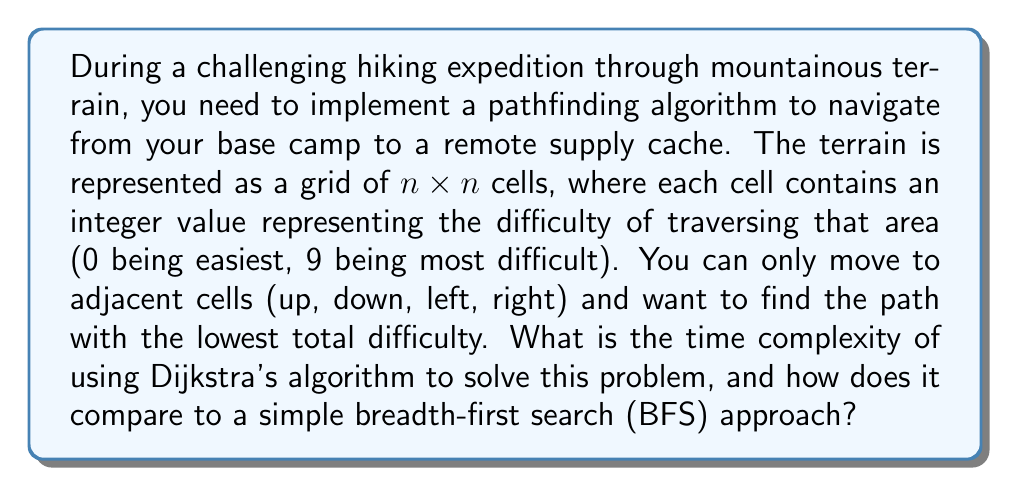Can you answer this question? To analyze the time complexity of Dijkstra's algorithm for this problem, let's break it down step by step:

1. Grid representation:
   The terrain is represented as an $n \times n$ grid, so the total number of cells (vertices) is $V = n^2$.

2. Edge connections:
   Each cell is connected to its adjacent cells (up to 4 neighbors), so the total number of edges is approximately $E = 4n^2 = 4V$.

3. Dijkstra's algorithm implementation:
   - Using a binary heap as a priority queue, the time complexity for Dijkstra's algorithm is $O((V + E) \log V)$.
   - Substituting our values: $O((n^2 + 4n^2) \log n^2) = O(5n^2 \log n^2) = O(n^2 \log n)$.

4. Comparison with BFS:
   - BFS has a time complexity of $O(V + E)$, which in this case would be $O(n^2 + 4n^2) = O(5n^2) = O(n^2)$.
   - However, BFS doesn't consider the difficulty values and would only find the path with the fewest steps, not necessarily the least difficult path.

5. Space complexity:
   Both algorithms have a space complexity of $O(V) = O(n^2)$ to store the grid and visited nodes.

Dijkstra's algorithm is more suitable for this problem because it considers the difficulty values and finds the optimal path. The additional $\log n$ factor in the time complexity is a reasonable trade-off for finding the best path through challenging terrain.
Answer: The time complexity of using Dijkstra's algorithm for this pathfinding problem is $O(n^2 \log n)$, where $n$ is the side length of the grid. This is more computationally expensive than a simple BFS approach, which would have a time complexity of $O(n^2)$, but Dijkstra's algorithm provides the optimal path considering terrain difficulty. 